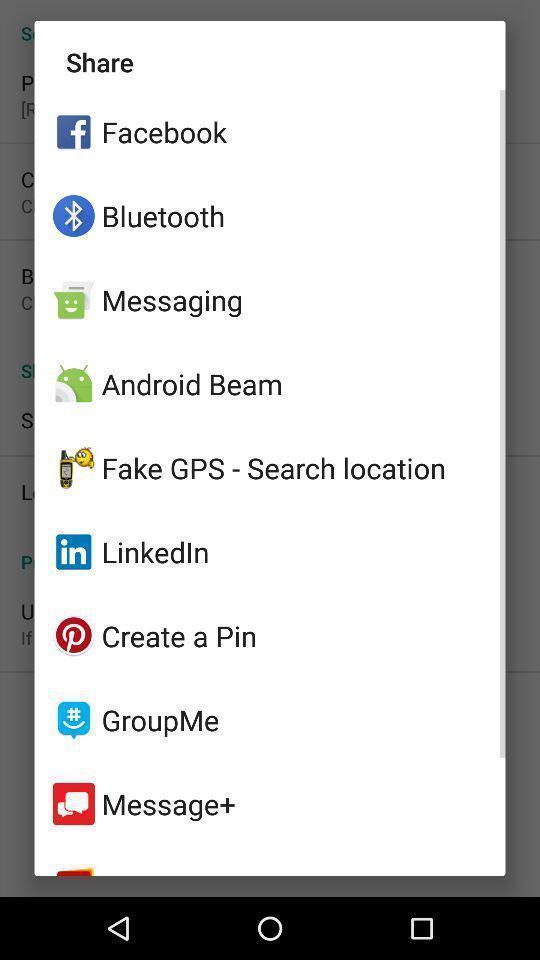Please provide a description for this image. Pop-up showing to share with different apps. 